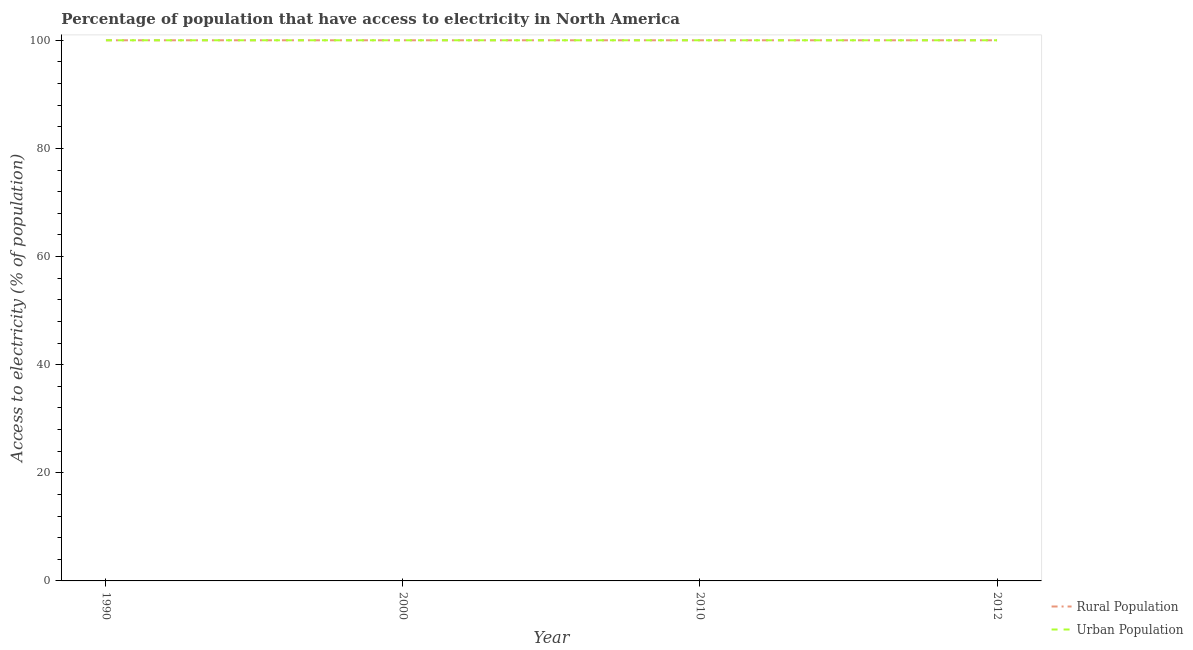Does the line corresponding to percentage of urban population having access to electricity intersect with the line corresponding to percentage of rural population having access to electricity?
Offer a very short reply. Yes. What is the percentage of urban population having access to electricity in 2000?
Your response must be concise. 100. Across all years, what is the maximum percentage of urban population having access to electricity?
Keep it short and to the point. 100. Across all years, what is the minimum percentage of rural population having access to electricity?
Your response must be concise. 100. In which year was the percentage of rural population having access to electricity maximum?
Keep it short and to the point. 1990. What is the total percentage of urban population having access to electricity in the graph?
Provide a short and direct response. 400. What is the average percentage of urban population having access to electricity per year?
Provide a short and direct response. 100. In the year 2012, what is the difference between the percentage of urban population having access to electricity and percentage of rural population having access to electricity?
Provide a succinct answer. 0. Is the difference between the percentage of rural population having access to electricity in 2000 and 2012 greater than the difference between the percentage of urban population having access to electricity in 2000 and 2012?
Provide a succinct answer. No. What is the difference between the highest and the second highest percentage of rural population having access to electricity?
Offer a very short reply. 0. What is the difference between the highest and the lowest percentage of rural population having access to electricity?
Make the answer very short. 0. Does the percentage of urban population having access to electricity monotonically increase over the years?
Offer a very short reply. No. Is the percentage of rural population having access to electricity strictly greater than the percentage of urban population having access to electricity over the years?
Provide a succinct answer. No. Is the percentage of rural population having access to electricity strictly less than the percentage of urban population having access to electricity over the years?
Your response must be concise. No. What is the difference between two consecutive major ticks on the Y-axis?
Your answer should be compact. 20. Are the values on the major ticks of Y-axis written in scientific E-notation?
Your response must be concise. No. Does the graph contain any zero values?
Your response must be concise. No. Does the graph contain grids?
Your answer should be compact. No. Where does the legend appear in the graph?
Give a very brief answer. Bottom right. How are the legend labels stacked?
Provide a succinct answer. Vertical. What is the title of the graph?
Keep it short and to the point. Percentage of population that have access to electricity in North America. Does "Non-solid fuel" appear as one of the legend labels in the graph?
Give a very brief answer. No. What is the label or title of the Y-axis?
Offer a very short reply. Access to electricity (% of population). What is the Access to electricity (% of population) of Urban Population in 1990?
Your answer should be compact. 100. What is the Access to electricity (% of population) in Rural Population in 2010?
Offer a very short reply. 100. What is the Access to electricity (% of population) of Rural Population in 2012?
Provide a short and direct response. 100. What is the Access to electricity (% of population) in Urban Population in 2012?
Your answer should be very brief. 100. Across all years, what is the maximum Access to electricity (% of population) in Urban Population?
Your answer should be very brief. 100. Across all years, what is the minimum Access to electricity (% of population) of Rural Population?
Give a very brief answer. 100. What is the difference between the Access to electricity (% of population) in Urban Population in 1990 and that in 2000?
Your answer should be compact. 0. What is the difference between the Access to electricity (% of population) of Rural Population in 1990 and that in 2010?
Keep it short and to the point. 0. What is the difference between the Access to electricity (% of population) of Urban Population in 1990 and that in 2010?
Offer a very short reply. 0. What is the difference between the Access to electricity (% of population) of Rural Population in 1990 and that in 2012?
Your answer should be very brief. 0. What is the difference between the Access to electricity (% of population) in Rural Population in 2000 and that in 2012?
Your answer should be very brief. 0. What is the difference between the Access to electricity (% of population) in Rural Population in 2010 and that in 2012?
Your answer should be very brief. 0. What is the difference between the Access to electricity (% of population) of Urban Population in 2010 and that in 2012?
Ensure brevity in your answer.  0. What is the difference between the Access to electricity (% of population) of Rural Population in 1990 and the Access to electricity (% of population) of Urban Population in 2010?
Provide a succinct answer. 0. What is the difference between the Access to electricity (% of population) in Rural Population in 2000 and the Access to electricity (% of population) in Urban Population in 2012?
Keep it short and to the point. 0. What is the average Access to electricity (% of population) in Rural Population per year?
Keep it short and to the point. 100. In the year 2000, what is the difference between the Access to electricity (% of population) in Rural Population and Access to electricity (% of population) in Urban Population?
Offer a very short reply. 0. In the year 2010, what is the difference between the Access to electricity (% of population) in Rural Population and Access to electricity (% of population) in Urban Population?
Offer a very short reply. 0. What is the ratio of the Access to electricity (% of population) in Rural Population in 1990 to that in 2000?
Offer a very short reply. 1. What is the ratio of the Access to electricity (% of population) in Urban Population in 1990 to that in 2000?
Ensure brevity in your answer.  1. What is the ratio of the Access to electricity (% of population) of Rural Population in 1990 to that in 2010?
Give a very brief answer. 1. What is the ratio of the Access to electricity (% of population) in Rural Population in 2000 to that in 2010?
Your answer should be compact. 1. What is the ratio of the Access to electricity (% of population) of Rural Population in 2010 to that in 2012?
Your response must be concise. 1. What is the difference between the highest and the second highest Access to electricity (% of population) of Urban Population?
Make the answer very short. 0. What is the difference between the highest and the lowest Access to electricity (% of population) of Rural Population?
Offer a very short reply. 0. What is the difference between the highest and the lowest Access to electricity (% of population) of Urban Population?
Offer a terse response. 0. 